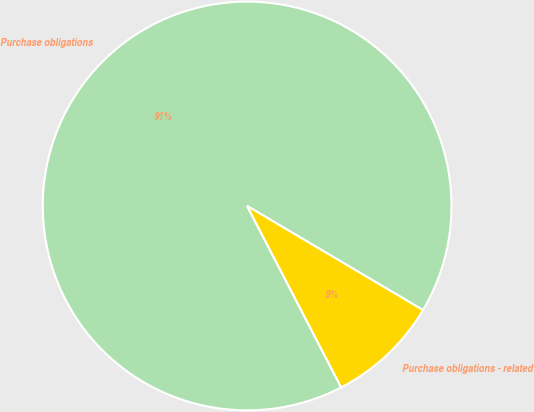<chart> <loc_0><loc_0><loc_500><loc_500><pie_chart><fcel>Purchase obligations<fcel>Purchase obligations - related<nl><fcel>91.12%<fcel>8.88%<nl></chart> 